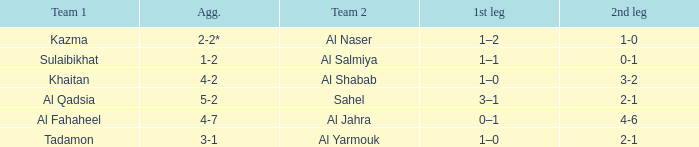What is the name of Team 2 with a Team 1 of Al Qadsia? Sahel. 